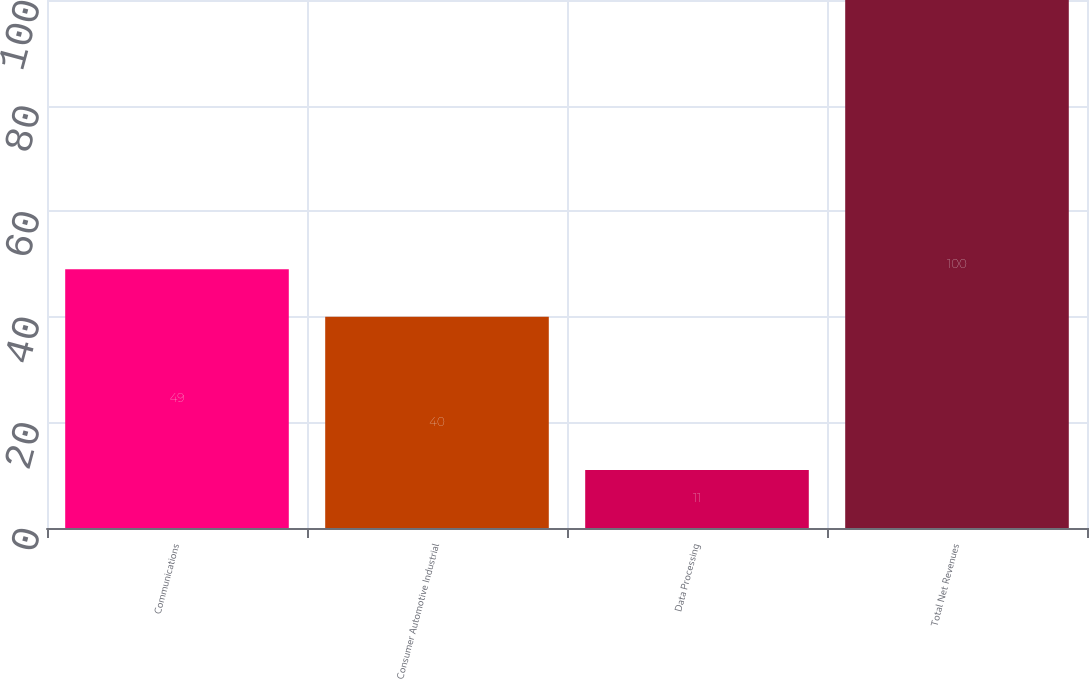Convert chart. <chart><loc_0><loc_0><loc_500><loc_500><bar_chart><fcel>Communications<fcel>Consumer Automotive Industrial<fcel>Data Processing<fcel>Total Net Revenues<nl><fcel>49<fcel>40<fcel>11<fcel>100<nl></chart> 